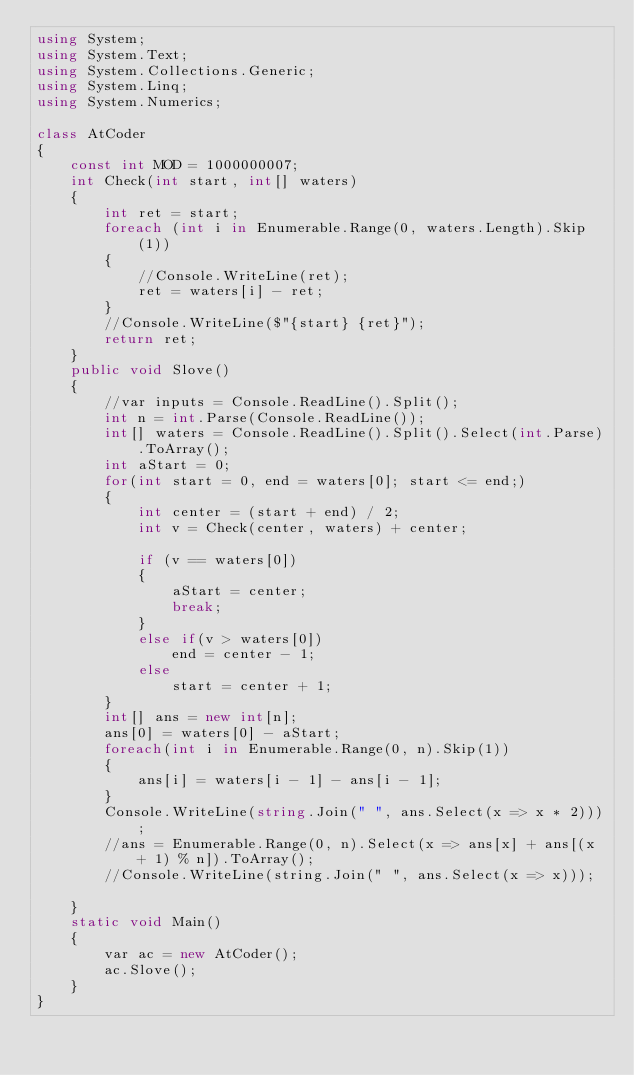<code> <loc_0><loc_0><loc_500><loc_500><_C#_>using System;
using System.Text;
using System.Collections.Generic;
using System.Linq;
using System.Numerics;

class AtCoder
{
    const int MOD = 1000000007;
    int Check(int start, int[] waters)
    {
        int ret = start;
        foreach (int i in Enumerable.Range(0, waters.Length).Skip(1))
        {
            //Console.WriteLine(ret);
            ret = waters[i] - ret;
        }
        //Console.WriteLine($"{start} {ret}");
        return ret;
    }
    public void Slove()
    {
        //var inputs = Console.ReadLine().Split();
        int n = int.Parse(Console.ReadLine());
        int[] waters = Console.ReadLine().Split().Select(int.Parse).ToArray();
        int aStart = 0;
        for(int start = 0, end = waters[0]; start <= end;)
        {
            int center = (start + end) / 2;
            int v = Check(center, waters) + center;

            if (v == waters[0])
            {
                aStart = center;
                break;
            }
            else if(v > waters[0])
                end = center - 1;
            else
                start = center + 1;
        }
        int[] ans = new int[n];
        ans[0] = waters[0] - aStart;
        foreach(int i in Enumerable.Range(0, n).Skip(1))
        {
            ans[i] = waters[i - 1] - ans[i - 1];
        }
        Console.WriteLine(string.Join(" ", ans.Select(x => x * 2)));
        //ans = Enumerable.Range(0, n).Select(x => ans[x] + ans[(x + 1) % n]).ToArray();
        //Console.WriteLine(string.Join(" ", ans.Select(x => x)));

    }
    static void Main()
    {
        var ac = new AtCoder();
        ac.Slove();
    }
}</code> 